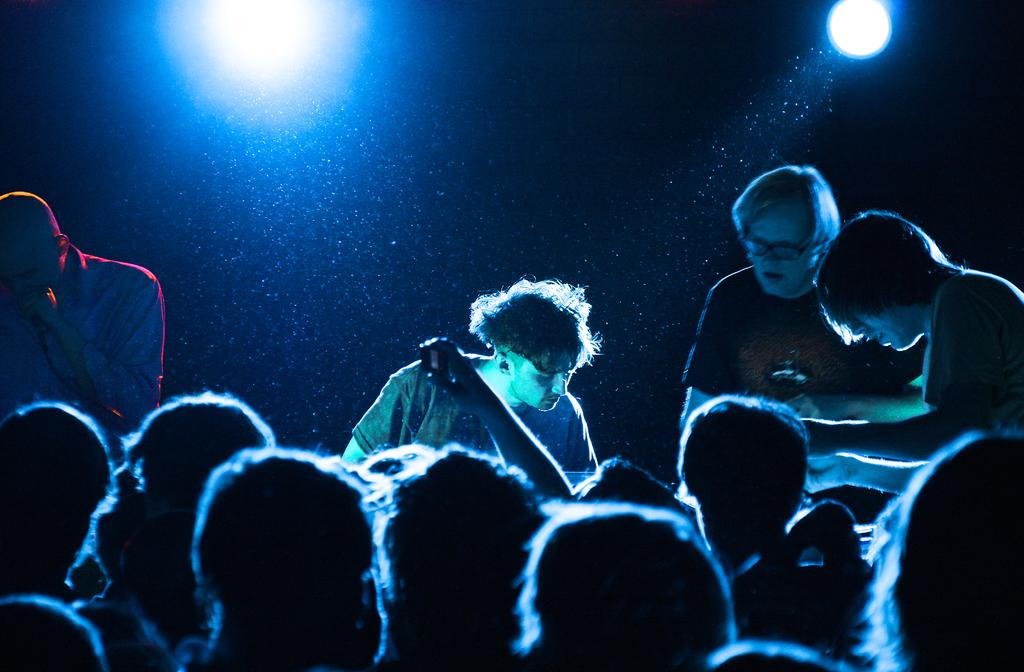How many people are present in the image? There are many people in the image. What type of event is taking place in the image? The scene appears to be a concert. What can be seen in the background of the image? There are lights in the background of the image. Where was the image likely taken? The image was likely taken in a room. What type of airplane can be seen in the image? There is no airplane present in the image. 